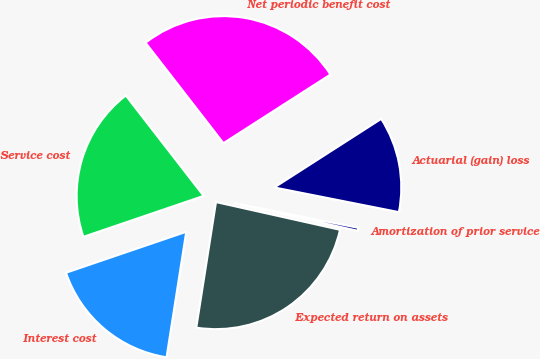Convert chart. <chart><loc_0><loc_0><loc_500><loc_500><pie_chart><fcel>Service cost<fcel>Interest cost<fcel>Expected return on assets<fcel>Amortization of prior service<fcel>Actuarial (gain) loss<fcel>Net periodic benefit cost<nl><fcel>19.73%<fcel>17.3%<fcel>23.98%<fcel>0.39%<fcel>12.19%<fcel>26.42%<nl></chart> 